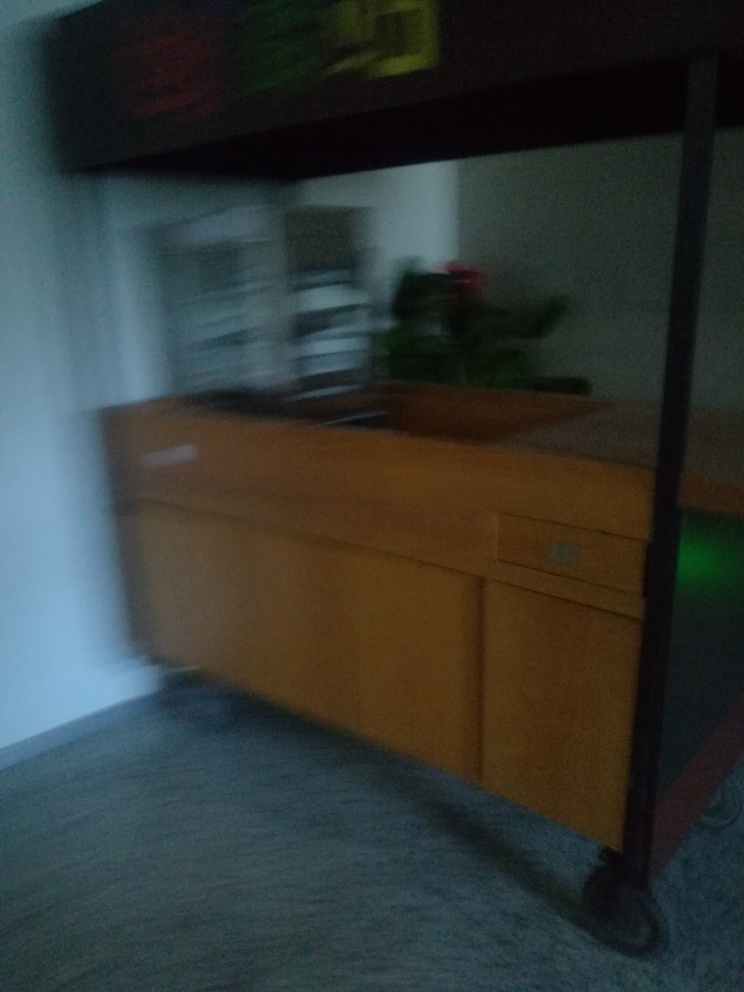What is the result of the motion blur?
A. Blur
B. Sharpness
C. Detail
Answer with the option's letter from the given choices directly.
 A. 